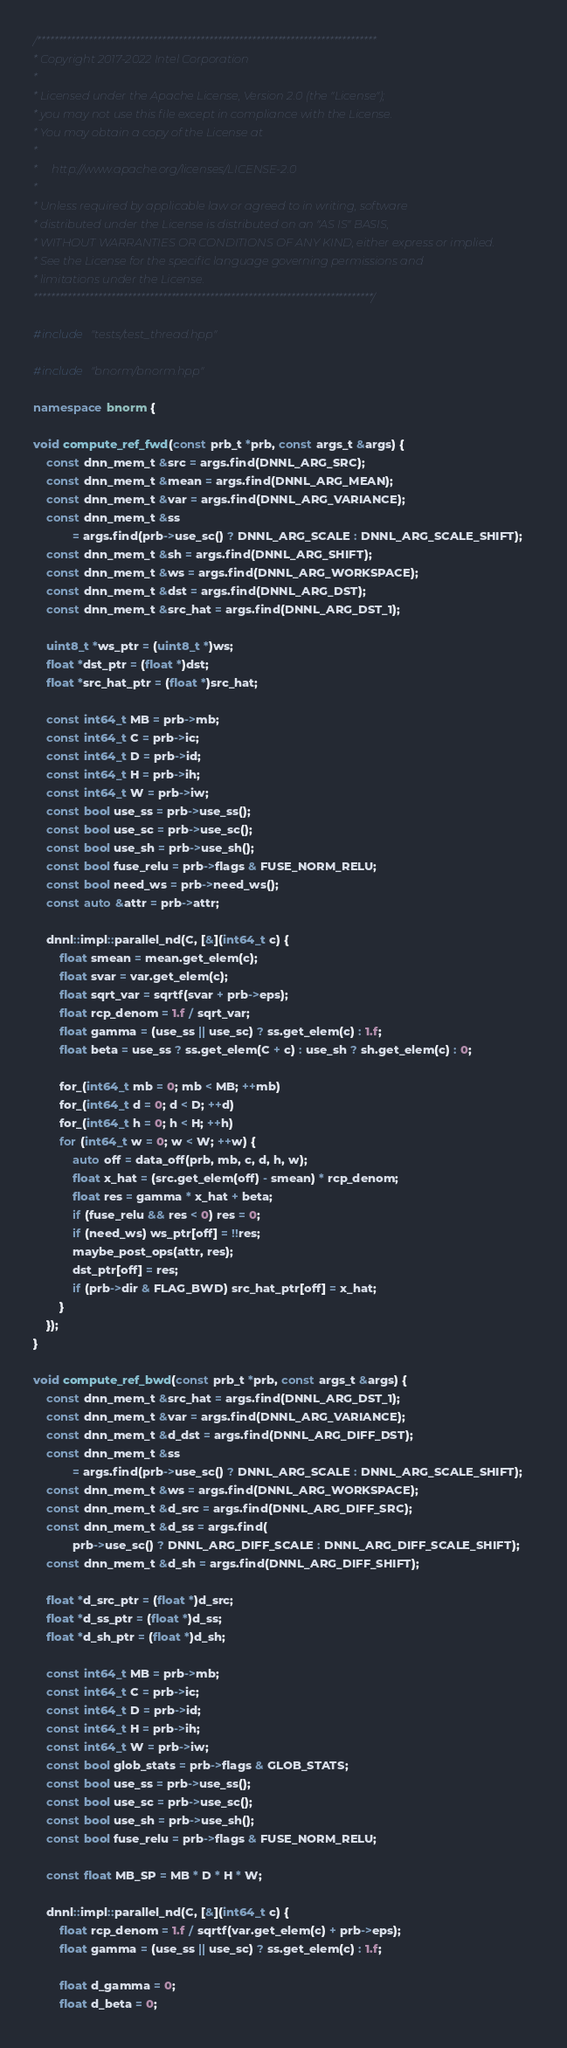Convert code to text. <code><loc_0><loc_0><loc_500><loc_500><_C++_>/*******************************************************************************
* Copyright 2017-2022 Intel Corporation
*
* Licensed under the Apache License, Version 2.0 (the "License");
* you may not use this file except in compliance with the License.
* You may obtain a copy of the License at
*
*     http://www.apache.org/licenses/LICENSE-2.0
*
* Unless required by applicable law or agreed to in writing, software
* distributed under the License is distributed on an "AS IS" BASIS,
* WITHOUT WARRANTIES OR CONDITIONS OF ANY KIND, either express or implied.
* See the License for the specific language governing permissions and
* limitations under the License.
*******************************************************************************/

#include "tests/test_thread.hpp"

#include "bnorm/bnorm.hpp"

namespace bnorm {

void compute_ref_fwd(const prb_t *prb, const args_t &args) {
    const dnn_mem_t &src = args.find(DNNL_ARG_SRC);
    const dnn_mem_t &mean = args.find(DNNL_ARG_MEAN);
    const dnn_mem_t &var = args.find(DNNL_ARG_VARIANCE);
    const dnn_mem_t &ss
            = args.find(prb->use_sc() ? DNNL_ARG_SCALE : DNNL_ARG_SCALE_SHIFT);
    const dnn_mem_t &sh = args.find(DNNL_ARG_SHIFT);
    const dnn_mem_t &ws = args.find(DNNL_ARG_WORKSPACE);
    const dnn_mem_t &dst = args.find(DNNL_ARG_DST);
    const dnn_mem_t &src_hat = args.find(DNNL_ARG_DST_1);

    uint8_t *ws_ptr = (uint8_t *)ws;
    float *dst_ptr = (float *)dst;
    float *src_hat_ptr = (float *)src_hat;

    const int64_t MB = prb->mb;
    const int64_t C = prb->ic;
    const int64_t D = prb->id;
    const int64_t H = prb->ih;
    const int64_t W = prb->iw;
    const bool use_ss = prb->use_ss();
    const bool use_sc = prb->use_sc();
    const bool use_sh = prb->use_sh();
    const bool fuse_relu = prb->flags & FUSE_NORM_RELU;
    const bool need_ws = prb->need_ws();
    const auto &attr = prb->attr;

    dnnl::impl::parallel_nd(C, [&](int64_t c) {
        float smean = mean.get_elem(c);
        float svar = var.get_elem(c);
        float sqrt_var = sqrtf(svar + prb->eps);
        float rcp_denom = 1.f / sqrt_var;
        float gamma = (use_ss || use_sc) ? ss.get_elem(c) : 1.f;
        float beta = use_ss ? ss.get_elem(C + c) : use_sh ? sh.get_elem(c) : 0;

        for_(int64_t mb = 0; mb < MB; ++mb)
        for_(int64_t d = 0; d < D; ++d)
        for_(int64_t h = 0; h < H; ++h)
        for (int64_t w = 0; w < W; ++w) {
            auto off = data_off(prb, mb, c, d, h, w);
            float x_hat = (src.get_elem(off) - smean) * rcp_denom;
            float res = gamma * x_hat + beta;
            if (fuse_relu && res < 0) res = 0;
            if (need_ws) ws_ptr[off] = !!res;
            maybe_post_ops(attr, res);
            dst_ptr[off] = res;
            if (prb->dir & FLAG_BWD) src_hat_ptr[off] = x_hat;
        }
    });
}

void compute_ref_bwd(const prb_t *prb, const args_t &args) {
    const dnn_mem_t &src_hat = args.find(DNNL_ARG_DST_1);
    const dnn_mem_t &var = args.find(DNNL_ARG_VARIANCE);
    const dnn_mem_t &d_dst = args.find(DNNL_ARG_DIFF_DST);
    const dnn_mem_t &ss
            = args.find(prb->use_sc() ? DNNL_ARG_SCALE : DNNL_ARG_SCALE_SHIFT);
    const dnn_mem_t &ws = args.find(DNNL_ARG_WORKSPACE);
    const dnn_mem_t &d_src = args.find(DNNL_ARG_DIFF_SRC);
    const dnn_mem_t &d_ss = args.find(
            prb->use_sc() ? DNNL_ARG_DIFF_SCALE : DNNL_ARG_DIFF_SCALE_SHIFT);
    const dnn_mem_t &d_sh = args.find(DNNL_ARG_DIFF_SHIFT);

    float *d_src_ptr = (float *)d_src;
    float *d_ss_ptr = (float *)d_ss;
    float *d_sh_ptr = (float *)d_sh;

    const int64_t MB = prb->mb;
    const int64_t C = prb->ic;
    const int64_t D = prb->id;
    const int64_t H = prb->ih;
    const int64_t W = prb->iw;
    const bool glob_stats = prb->flags & GLOB_STATS;
    const bool use_ss = prb->use_ss();
    const bool use_sc = prb->use_sc();
    const bool use_sh = prb->use_sh();
    const bool fuse_relu = prb->flags & FUSE_NORM_RELU;

    const float MB_SP = MB * D * H * W;

    dnnl::impl::parallel_nd(C, [&](int64_t c) {
        float rcp_denom = 1.f / sqrtf(var.get_elem(c) + prb->eps);
        float gamma = (use_ss || use_sc) ? ss.get_elem(c) : 1.f;

        float d_gamma = 0;
        float d_beta = 0;
</code> 